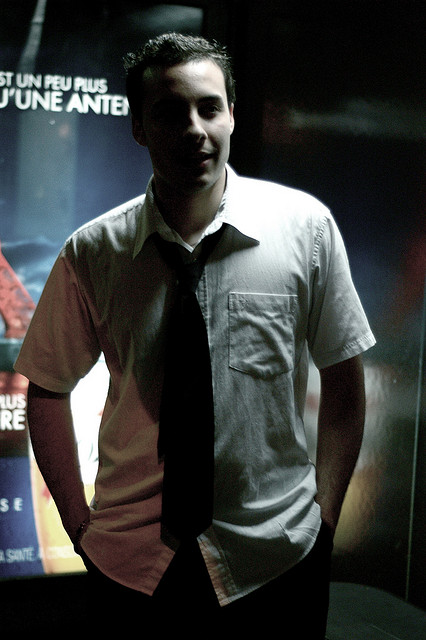Identify the text contained in this image. ANTEN PLUS UN RE US ST 